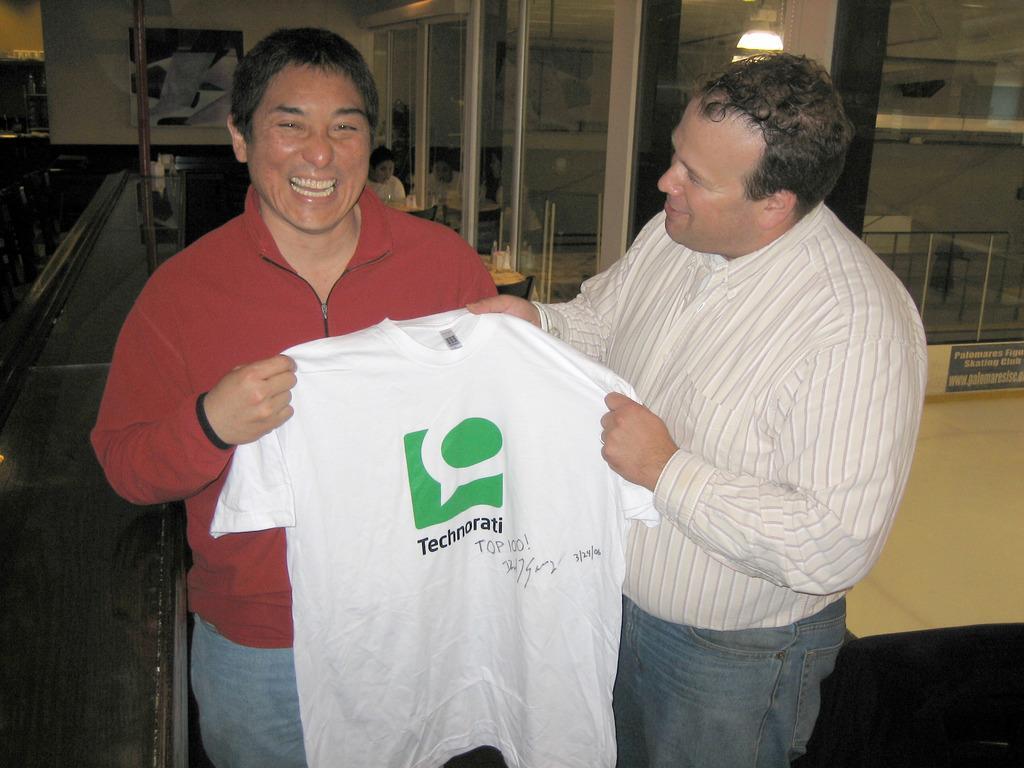How would you summarize this image in a sentence or two? In this image there are two men who are holding the t-shirt. In the background there are glass doors. In the middle there are tables on which there are glasses. There is a poster to the wall. 